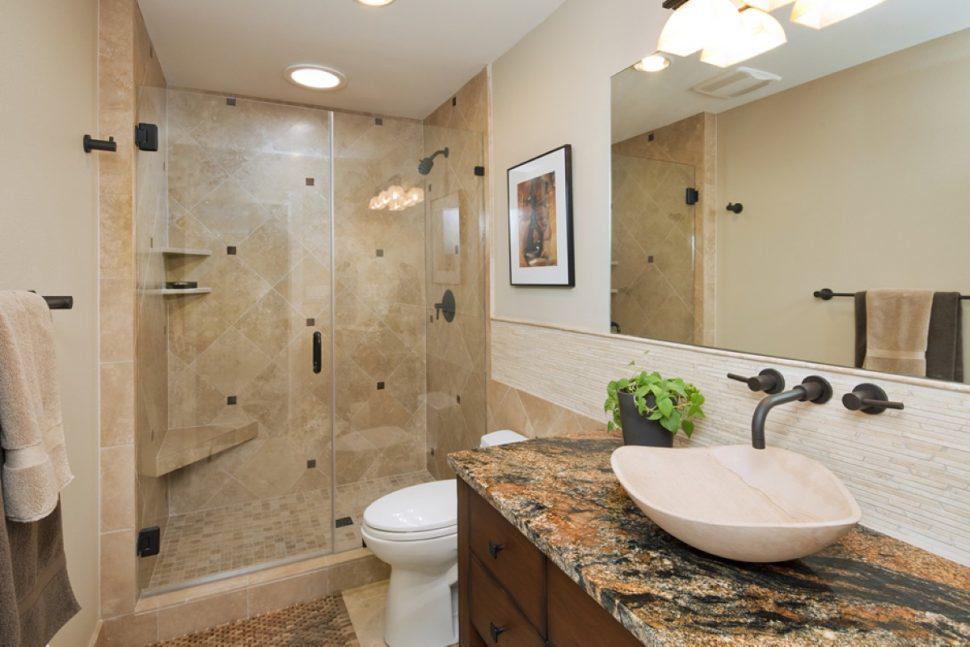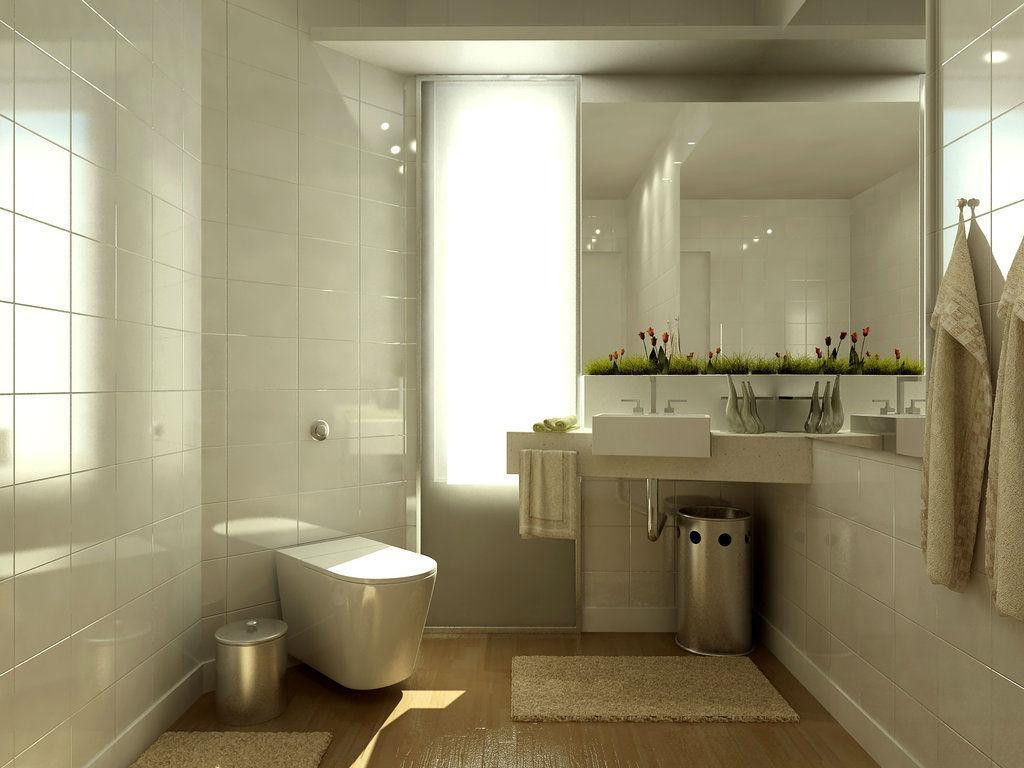The first image is the image on the left, the second image is the image on the right. For the images displayed, is the sentence "In one image, a shower stall is on the far end of a bathroom that also features a light colored vanity with one drawer and two doors." factually correct? Answer yes or no. No. 